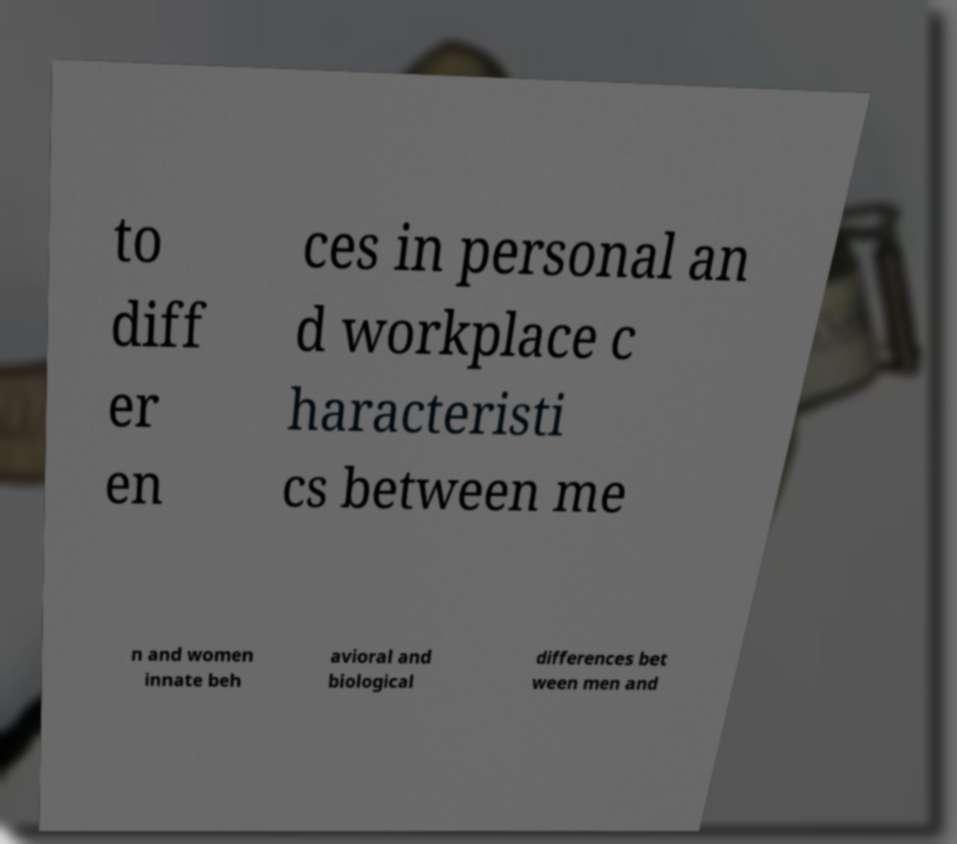What messages or text are displayed in this image? I need them in a readable, typed format. to diff er en ces in personal an d workplace c haracteristi cs between me n and women innate beh avioral and biological differences bet ween men and 